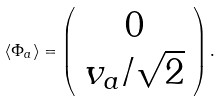Convert formula to latex. <formula><loc_0><loc_0><loc_500><loc_500>\langle \Phi _ { a } \rangle = \left ( \begin{array} { c } 0 \\ v _ { a } / \sqrt { 2 } \end{array} \right ) .</formula> 